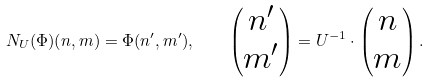<formula> <loc_0><loc_0><loc_500><loc_500>N _ { U } ( \Phi ) ( n , m ) = \Phi ( n ^ { \prime } , m ^ { \prime } ) , \quad \begin{pmatrix} n ^ { \prime } \\ m ^ { \prime } \end{pmatrix} = U ^ { - 1 } \cdot \begin{pmatrix} n \\ m \end{pmatrix} .</formula> 